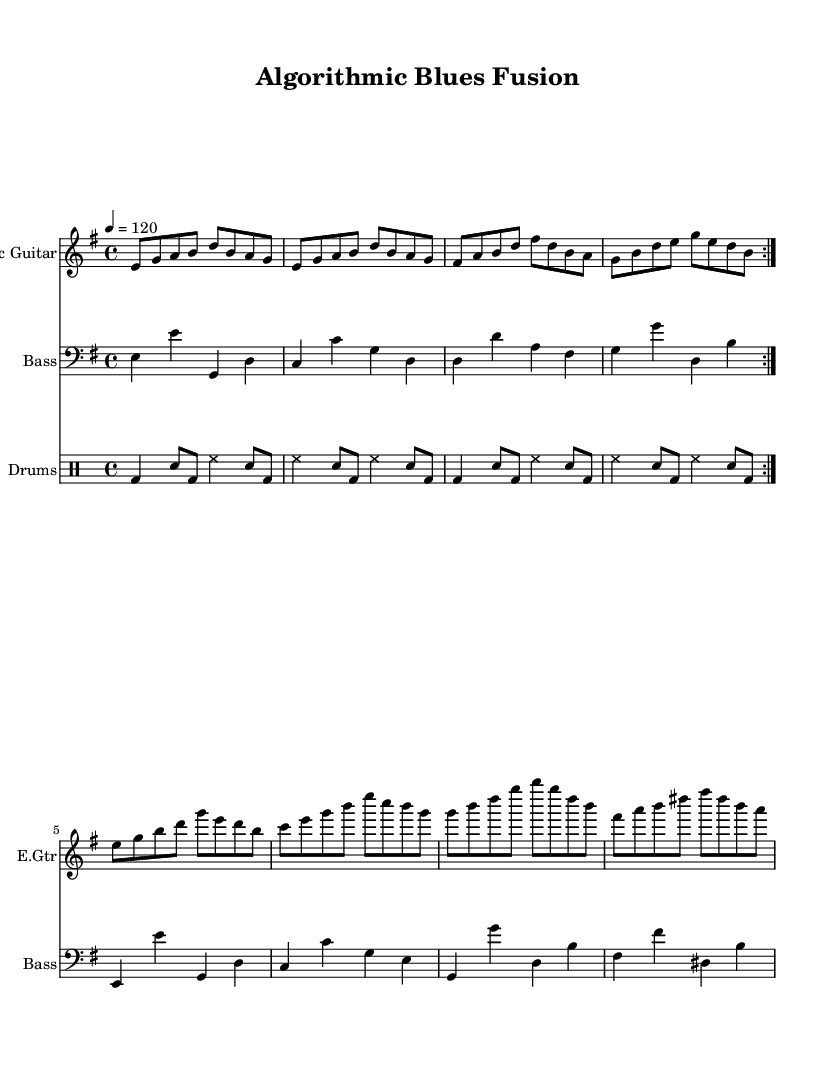What is the key signature of this music? The music is in E minor, which has one sharp (F#). This can be determined by looking at the key signature indicated at the beginning of the score.
Answer: E minor What is the time signature of this music? The time signature is 4/4, which means there are four beats in each measure and the quarter note gets one beat. This can also be observed as it is presented at the start of the piece.
Answer: 4/4 What is the tempo marking for this piece? The tempo marking is 120 beats per minute, indicated by “\tempo 4 = 120” at the beginning of the sheet. It specifies how fast the piece should be played.
Answer: 120 How many measures are repeated in the electric guitar part? There are 2 measures repeated in the electric guitar part, as indicated by the “\repeat volta 2” command. This means the section should be played twice before moving on.
Answer: 2 What makes this piece a fusion of electric blues? The piece incorporates electric guitar, bass guitar, and drums typically associated with electric blues, along with improvisational elements. The use of the electric guitar is prominent, and the laid-back rhythms reflect blues traditions.
Answer: Electric guitar, improvisation Which instrument plays the lowest notes in this score? The bass guitar plays the lowest notes. It is written in the bass clef, consisting of lower pitch notes compared to the guitar and drums, which are in treble and percussion notation respectively.
Answer: Bass guitar What type of improvisation is hinted at in this score? The score suggests algorithm-inspired improvisation as it includes repeated sections that allow for variations and creative expression within a structured framework. This approach draws on mathematical and systematic methods for exploring musical ideas.
Answer: Algorithm-inspired improvisation 